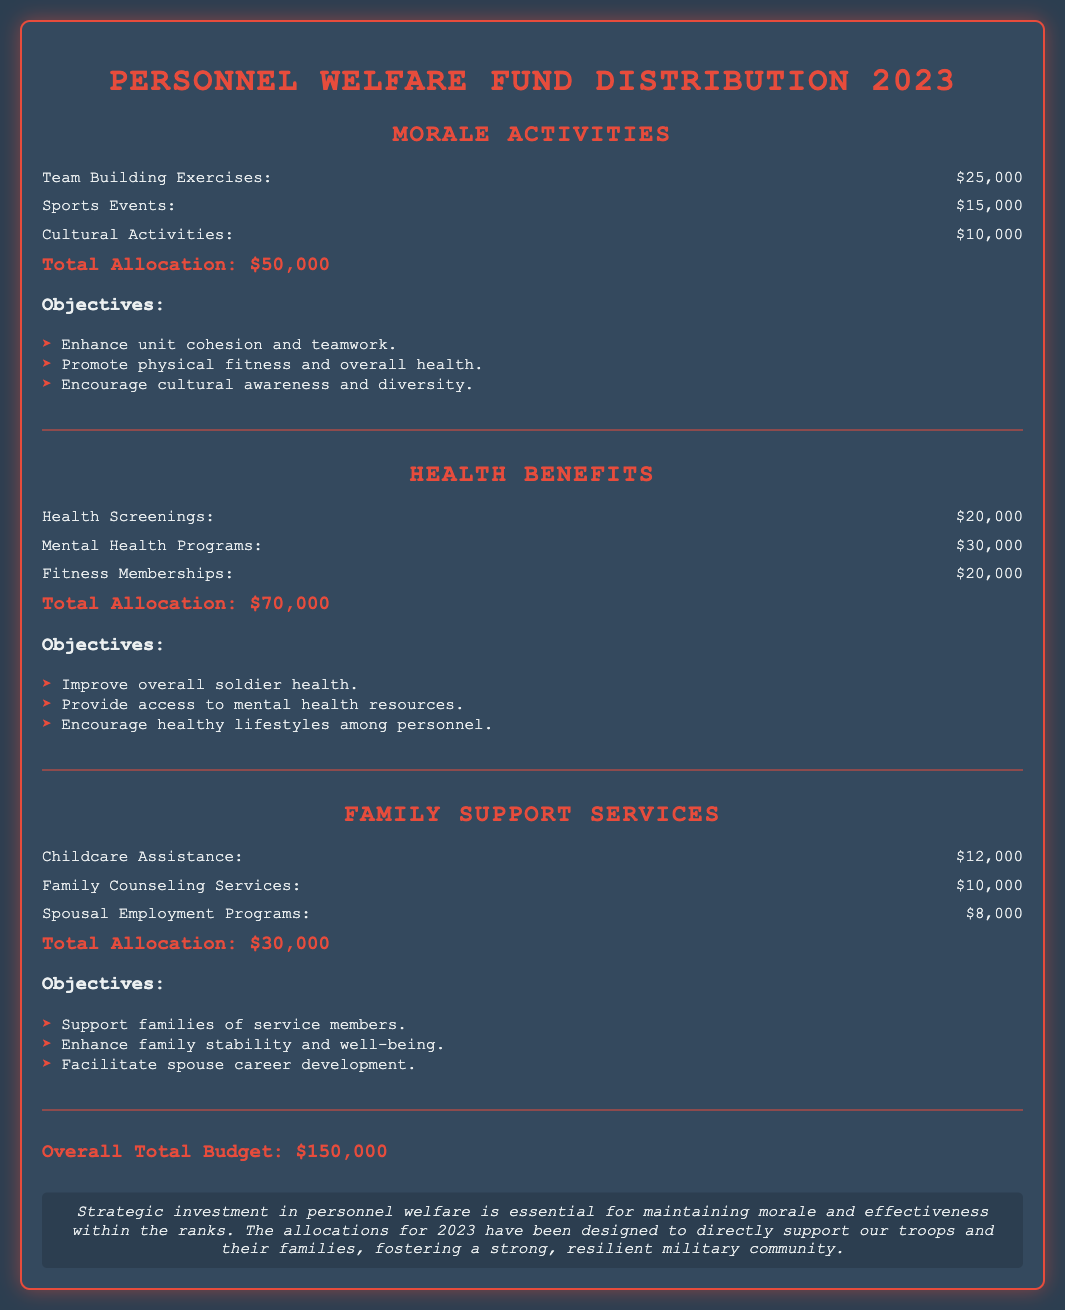What is the total allocation for Morale Activities? The total allocation for Morale Activities is stated at the end of the section and is $50,000.
Answer: $50,000 How much is allocated for Mental Health Programs? The specific allocation for Mental Health Programs is listed under Health Benefits and is $30,000.
Answer: $30,000 What is the total budget for Family Support Services? The total budget for Family Support Services is summarized at the end of the section and is $30,000.
Answer: $30,000 What are the objectives of Health Benefits? The objectives for Health Benefits are listed in bullet points right after the allocations, detailing improvement of soldier health, access to mental health resources, and encouragement of healthy lifestyles.
Answer: Improve overall soldier health, Provide access to mental health resources, Encourage healthy lifestyles among personnel What is the overall total budget for 2023? The overall total budget is stated at the bottom of the document summing all sections and is $150,000.
Answer: $150,000 Which morale activity has the highest allocation? The highest allocation among morale activities is for Team Building Exercises, which is $25,000.
Answer: Team Building Exercises What support does the Family Support Services provide? The Family Support Services provide assistance with childcare, counseling, and employment programs for spouses, as outlined in the section.
Answer: Childcare Assistance, Family Counseling Services, Spousal Employment Programs What is the budget allocation for Sports Events? The budget allocation for Sports Events is specified in the Morale Activities section and is $15,000.
Answer: $15,000 What is the primary reason for the personnel welfare fund allocations? The conclusion of the document indicates that the primary reason for the allocations is to maintain morale and effectiveness within the ranks.
Answer: Maintain morale and effectiveness 